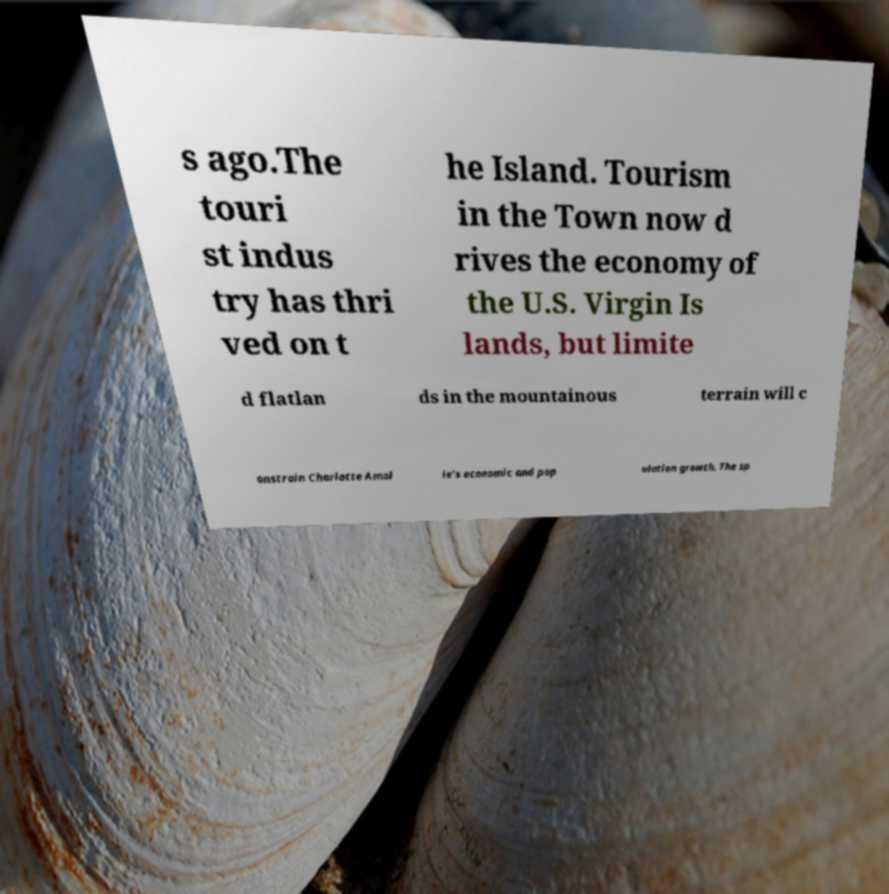What messages or text are displayed in this image? I need them in a readable, typed format. s ago.The touri st indus try has thri ved on t he Island. Tourism in the Town now d rives the economy of the U.S. Virgin Is lands, but limite d flatlan ds in the mountainous terrain will c onstrain Charlotte Amal ie's economic and pop ulation growth. The sp 